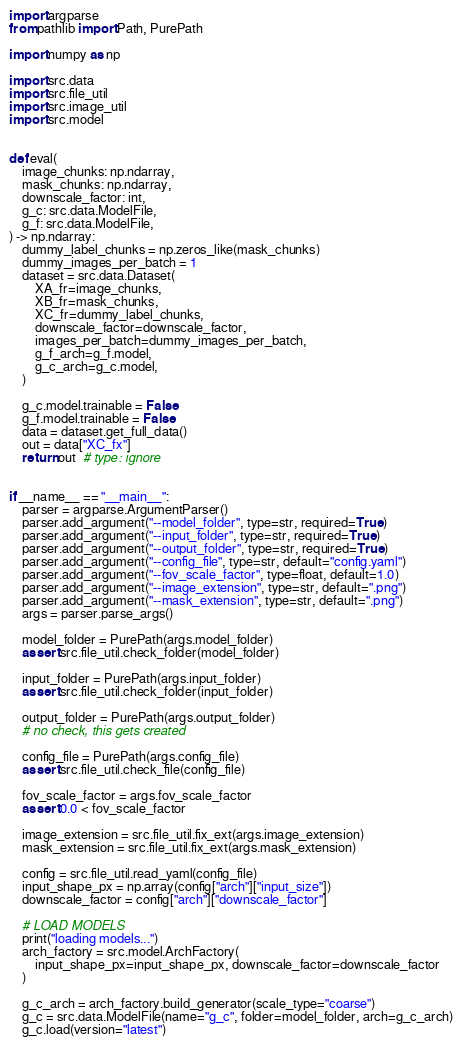<code> <loc_0><loc_0><loc_500><loc_500><_Python_>import argparse
from pathlib import Path, PurePath

import numpy as np

import src.data
import src.file_util
import src.image_util
import src.model


def eval(
    image_chunks: np.ndarray,
    mask_chunks: np.ndarray,
    downscale_factor: int,
    g_c: src.data.ModelFile,
    g_f: src.data.ModelFile,
) -> np.ndarray:
    dummy_label_chunks = np.zeros_like(mask_chunks)
    dummy_images_per_batch = 1
    dataset = src.data.Dataset(
        XA_fr=image_chunks,
        XB_fr=mask_chunks,
        XC_fr=dummy_label_chunks,
        downscale_factor=downscale_factor,
        images_per_batch=dummy_images_per_batch,
        g_f_arch=g_f.model,
        g_c_arch=g_c.model,
    )

    g_c.model.trainable = False
    g_f.model.trainable = False
    data = dataset.get_full_data()
    out = data["XC_fx"]
    return out  # type: ignore


if __name__ == "__main__":
    parser = argparse.ArgumentParser()
    parser.add_argument("--model_folder", type=str, required=True)
    parser.add_argument("--input_folder", type=str, required=True)
    parser.add_argument("--output_folder", type=str, required=True)
    parser.add_argument("--config_file", type=str, default="config.yaml")
    parser.add_argument("--fov_scale_factor", type=float, default=1.0)
    parser.add_argument("--image_extension", type=str, default=".png")
    parser.add_argument("--mask_extension", type=str, default=".png")
    args = parser.parse_args()

    model_folder = PurePath(args.model_folder)
    assert src.file_util.check_folder(model_folder)

    input_folder = PurePath(args.input_folder)
    assert src.file_util.check_folder(input_folder)

    output_folder = PurePath(args.output_folder)
    # no check, this gets created

    config_file = PurePath(args.config_file)
    assert src.file_util.check_file(config_file)

    fov_scale_factor = args.fov_scale_factor
    assert 0.0 < fov_scale_factor

    image_extension = src.file_util.fix_ext(args.image_extension)
    mask_extension = src.file_util.fix_ext(args.mask_extension)

    config = src.file_util.read_yaml(config_file)
    input_shape_px = np.array(config["arch"]["input_size"])
    downscale_factor = config["arch"]["downscale_factor"]

    # LOAD MODELS
    print("loading models...")
    arch_factory = src.model.ArchFactory(
        input_shape_px=input_shape_px, downscale_factor=downscale_factor
    )

    g_c_arch = arch_factory.build_generator(scale_type="coarse")
    g_c = src.data.ModelFile(name="g_c", folder=model_folder, arch=g_c_arch)
    g_c.load(version="latest")
</code> 